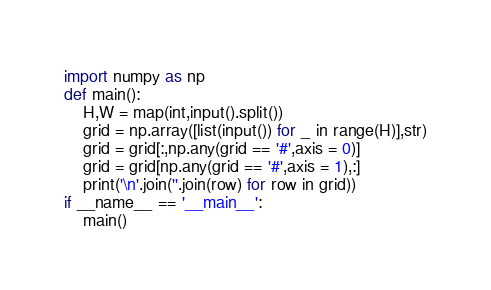Convert code to text. <code><loc_0><loc_0><loc_500><loc_500><_Python_>import numpy as np
def main():
    H,W = map(int,input().split())
    grid = np.array([list(input()) for _ in range(H)],str)
    grid = grid[:,np.any(grid == '#',axis = 0)]
    grid = grid[np.any(grid == '#',axis = 1),:]
    print('\n'.join(''.join(row) for row in grid))
if __name__ == '__main__':
    main()</code> 